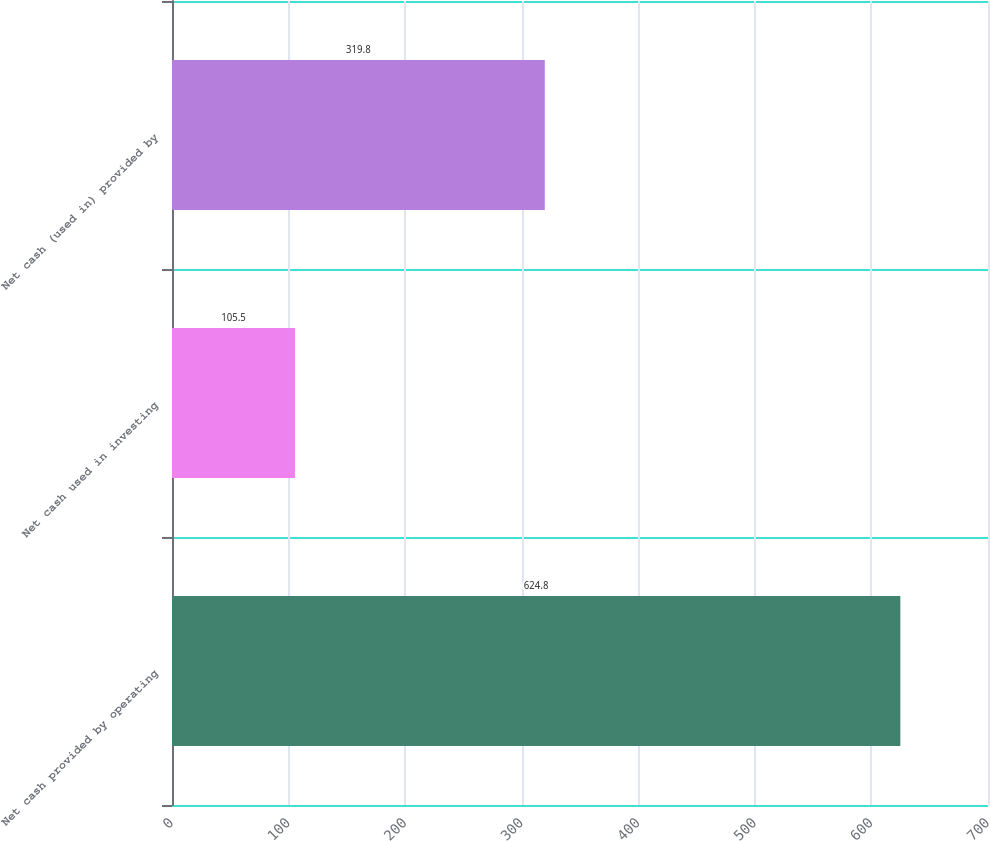Convert chart. <chart><loc_0><loc_0><loc_500><loc_500><bar_chart><fcel>Net cash provided by operating<fcel>Net cash used in investing<fcel>Net cash (used in) provided by<nl><fcel>624.8<fcel>105.5<fcel>319.8<nl></chart> 